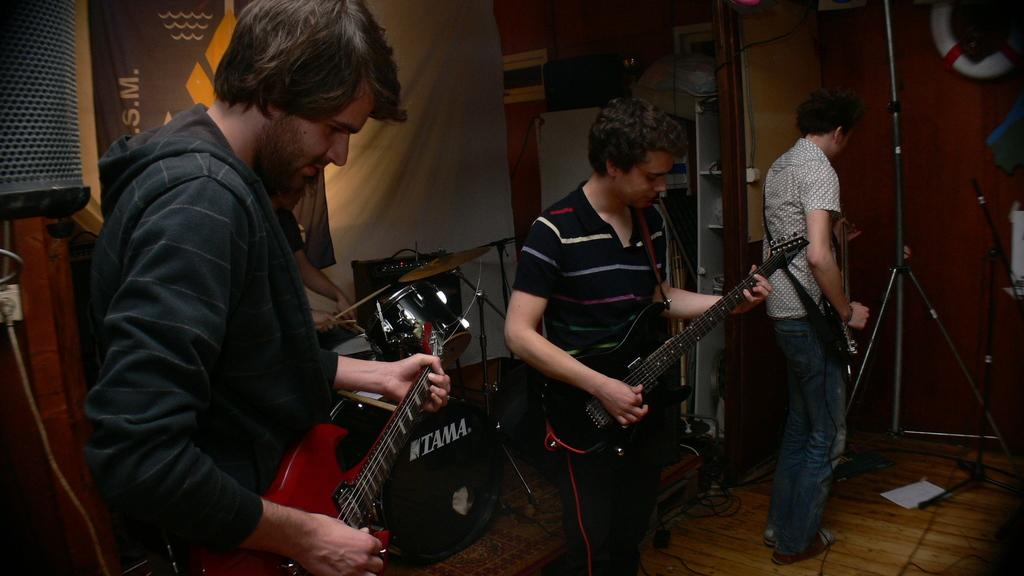How many people are in the image? There are three men in the image. What are the men holding in the image? The men are holding guitars. What can be seen in the background of the image? There is a tripod and drums in the background of the image. What type of theory can be seen being tested in the image? There is no theory being tested in the image; it features three men holding guitars and a background with a tripod and drums. 